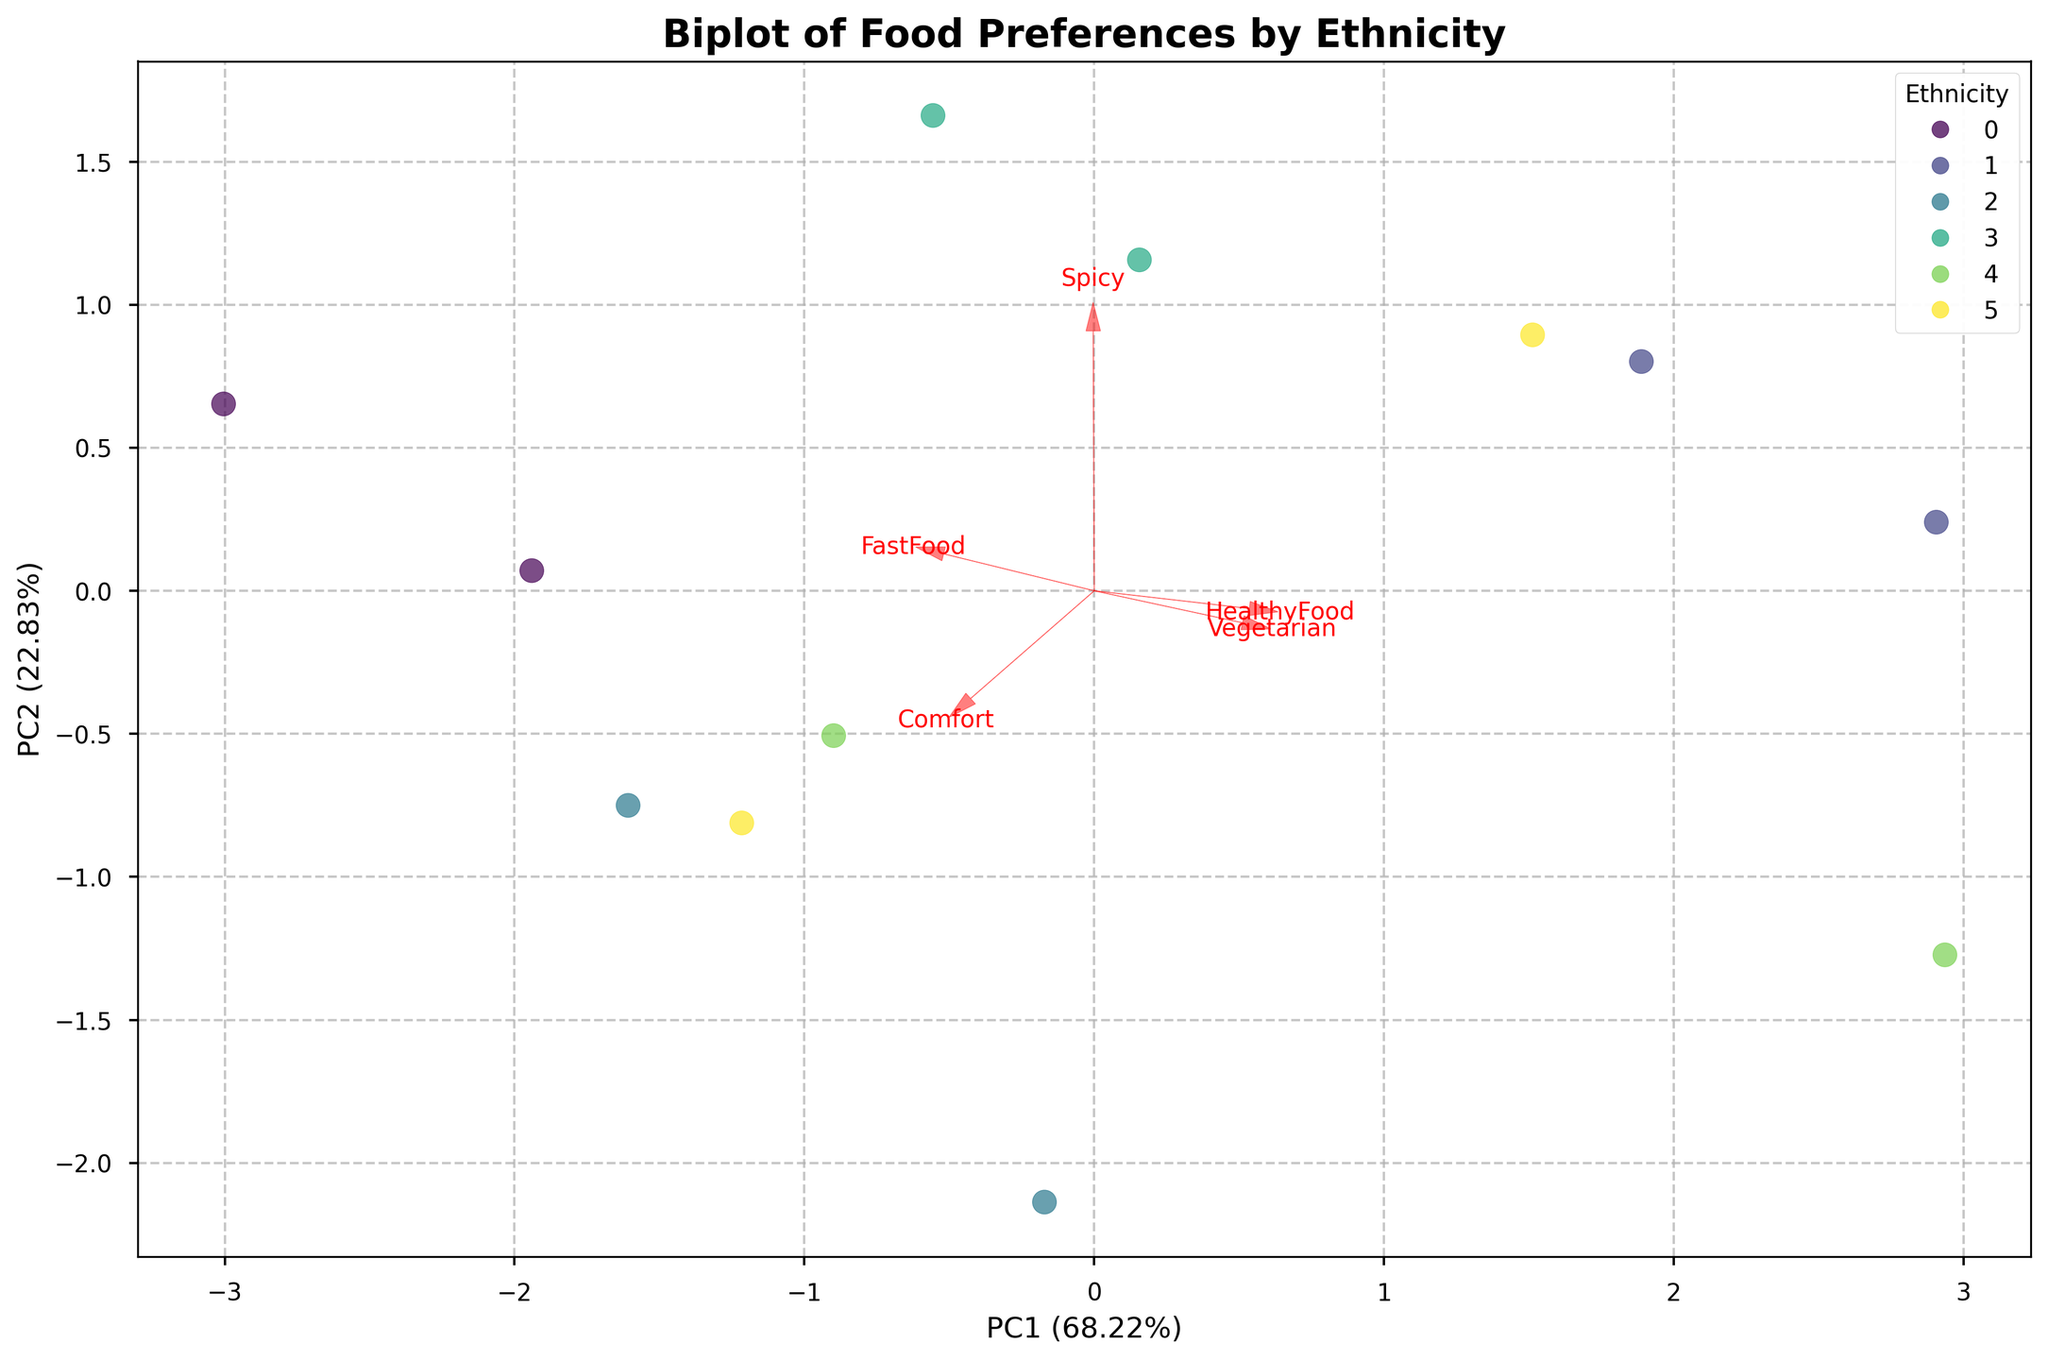What is the title of the plot? The title is usually positioned at the top of the figure. Titles provide a quick summary of what the figure represents. Here, it should give an idea about the content and context of the plot.
Answer: Biplot of Food Preferences by Ethnicity How many variables are represented by arrows in the plot? Arrows in a biplot represent the original variables. The number of arrows corresponds to the number of variables whose influence can be visualized in the PCA space.
Answer: Five What does PC1 represent in the figure? PC1 is the first principal component and is usually visible on the x-axis. The x-axis label also shows the percentage of variance explained by PC1 in the data.
Answer: Principal Component 1 explaining a certain percentage of variance Which ethnic group is represented by the highest number of data points in the plot? The number of data points for each ethnic group can be inferred from the legend and the scatter plot colors. Comparing the counts for each ethnic group will reveal which has the highest representation.
Answer: African American Which food preference appears to be the most positively correlated with the PC2 axis? To determine the correlation, look at the direction and length of the arrows representing each food preference variable. The one pointing mostly in the direction of PC2 (y-axis) is the most positively correlated with it.
Answer: HealthyFood How close are ‘FastFood’ and ‘Comfort’ preferences in their vector directions? In a biplot, the direction of the arrows relative to each other indicates the relationship. Look at the angles formed by the vectors of ‘FastFood’ and ‘Comfort’ to determine their similarity.
Answer: Quite close, with similar directions Which has a stronger influence on PC1: Spicy or Vegetarian preferences? Compare the lengths of the arrows for the variables along the x-axis. The variable with the longer vector in the direction of PC1 (x-axis) has a stronger influence.
Answer: Spicy For which ethnic group does the majority of data points lie further from the origin? Check which ethnic group’s points are spread out farther from the center of the plot. The group's points that lie at a greater distance from the origin are the ones further from the center.
Answer: Mixed Race Are there any ethnic groups whose data points are tightly clustered together? Observe the scatter plot and identify if points of any ethnic group are closely packed together, indicating less variance within that group’s preferences.
Answer: Yes, Asian What percentage of the variance in the data is explained by the first two principal components? The x and y axis labels usually show the variance percentage explained by PC1 and PC2. Sum these percentages to get the total variance explained by both principal components.
Answer: The sum of the percentages of PC1 and PC2 values in axis labels Which food preference has the least influence on both PC1 and PC2 combined? Identify the shortest vector among all the food preferences as it indicates the least influence on the combined principal components.
Answer: Vegetarian 